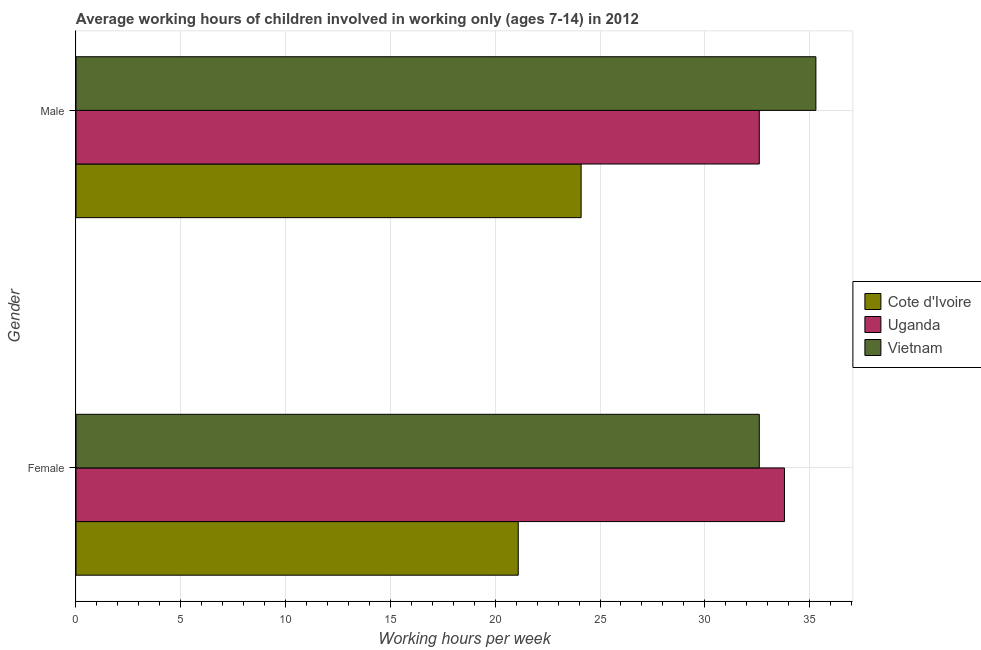How many different coloured bars are there?
Give a very brief answer. 3. How many groups of bars are there?
Provide a succinct answer. 2. Are the number of bars on each tick of the Y-axis equal?
Ensure brevity in your answer.  Yes. How many bars are there on the 1st tick from the top?
Your response must be concise. 3. How many bars are there on the 2nd tick from the bottom?
Keep it short and to the point. 3. What is the label of the 2nd group of bars from the top?
Your answer should be compact. Female. What is the average working hour of male children in Cote d'Ivoire?
Provide a short and direct response. 24.1. Across all countries, what is the maximum average working hour of male children?
Offer a very short reply. 35.3. Across all countries, what is the minimum average working hour of female children?
Offer a very short reply. 21.1. In which country was the average working hour of male children maximum?
Your answer should be compact. Vietnam. In which country was the average working hour of male children minimum?
Offer a terse response. Cote d'Ivoire. What is the total average working hour of female children in the graph?
Make the answer very short. 87.5. What is the difference between the average working hour of male children in Cote d'Ivoire and that in Uganda?
Provide a succinct answer. -8.5. What is the average average working hour of male children per country?
Ensure brevity in your answer.  30.67. What is the difference between the average working hour of male children and average working hour of female children in Vietnam?
Your response must be concise. 2.7. In how many countries, is the average working hour of female children greater than 3 hours?
Ensure brevity in your answer.  3. What is the ratio of the average working hour of male children in Cote d'Ivoire to that in Vietnam?
Provide a succinct answer. 0.68. What does the 3rd bar from the top in Female represents?
Provide a short and direct response. Cote d'Ivoire. What does the 2nd bar from the bottom in Female represents?
Make the answer very short. Uganda. How many bars are there?
Give a very brief answer. 6. How many countries are there in the graph?
Your answer should be compact. 3. What is the difference between two consecutive major ticks on the X-axis?
Keep it short and to the point. 5. Are the values on the major ticks of X-axis written in scientific E-notation?
Give a very brief answer. No. Does the graph contain grids?
Your response must be concise. Yes. How many legend labels are there?
Provide a short and direct response. 3. How are the legend labels stacked?
Ensure brevity in your answer.  Vertical. What is the title of the graph?
Your answer should be very brief. Average working hours of children involved in working only (ages 7-14) in 2012. Does "Austria" appear as one of the legend labels in the graph?
Ensure brevity in your answer.  No. What is the label or title of the X-axis?
Ensure brevity in your answer.  Working hours per week. What is the label or title of the Y-axis?
Keep it short and to the point. Gender. What is the Working hours per week of Cote d'Ivoire in Female?
Your answer should be very brief. 21.1. What is the Working hours per week in Uganda in Female?
Ensure brevity in your answer.  33.8. What is the Working hours per week of Vietnam in Female?
Ensure brevity in your answer.  32.6. What is the Working hours per week in Cote d'Ivoire in Male?
Give a very brief answer. 24.1. What is the Working hours per week of Uganda in Male?
Give a very brief answer. 32.6. What is the Working hours per week in Vietnam in Male?
Your answer should be very brief. 35.3. Across all Gender, what is the maximum Working hours per week in Cote d'Ivoire?
Offer a very short reply. 24.1. Across all Gender, what is the maximum Working hours per week in Uganda?
Make the answer very short. 33.8. Across all Gender, what is the maximum Working hours per week in Vietnam?
Keep it short and to the point. 35.3. Across all Gender, what is the minimum Working hours per week in Cote d'Ivoire?
Provide a succinct answer. 21.1. Across all Gender, what is the minimum Working hours per week in Uganda?
Give a very brief answer. 32.6. Across all Gender, what is the minimum Working hours per week of Vietnam?
Make the answer very short. 32.6. What is the total Working hours per week of Cote d'Ivoire in the graph?
Make the answer very short. 45.2. What is the total Working hours per week of Uganda in the graph?
Give a very brief answer. 66.4. What is the total Working hours per week of Vietnam in the graph?
Offer a terse response. 67.9. What is the difference between the Working hours per week of Uganda in Female and that in Male?
Make the answer very short. 1.2. What is the difference between the Working hours per week in Uganda in Female and the Working hours per week in Vietnam in Male?
Offer a terse response. -1.5. What is the average Working hours per week in Cote d'Ivoire per Gender?
Provide a succinct answer. 22.6. What is the average Working hours per week in Uganda per Gender?
Your answer should be very brief. 33.2. What is the average Working hours per week in Vietnam per Gender?
Keep it short and to the point. 33.95. What is the difference between the Working hours per week in Cote d'Ivoire and Working hours per week in Uganda in Female?
Give a very brief answer. -12.7. What is the difference between the Working hours per week in Uganda and Working hours per week in Vietnam in Male?
Your response must be concise. -2.7. What is the ratio of the Working hours per week in Cote d'Ivoire in Female to that in Male?
Your response must be concise. 0.88. What is the ratio of the Working hours per week in Uganda in Female to that in Male?
Ensure brevity in your answer.  1.04. What is the ratio of the Working hours per week in Vietnam in Female to that in Male?
Provide a short and direct response. 0.92. What is the difference between the highest and the second highest Working hours per week in Uganda?
Ensure brevity in your answer.  1.2. What is the difference between the highest and the second highest Working hours per week of Vietnam?
Make the answer very short. 2.7. What is the difference between the highest and the lowest Working hours per week of Cote d'Ivoire?
Make the answer very short. 3. What is the difference between the highest and the lowest Working hours per week in Uganda?
Your response must be concise. 1.2. 